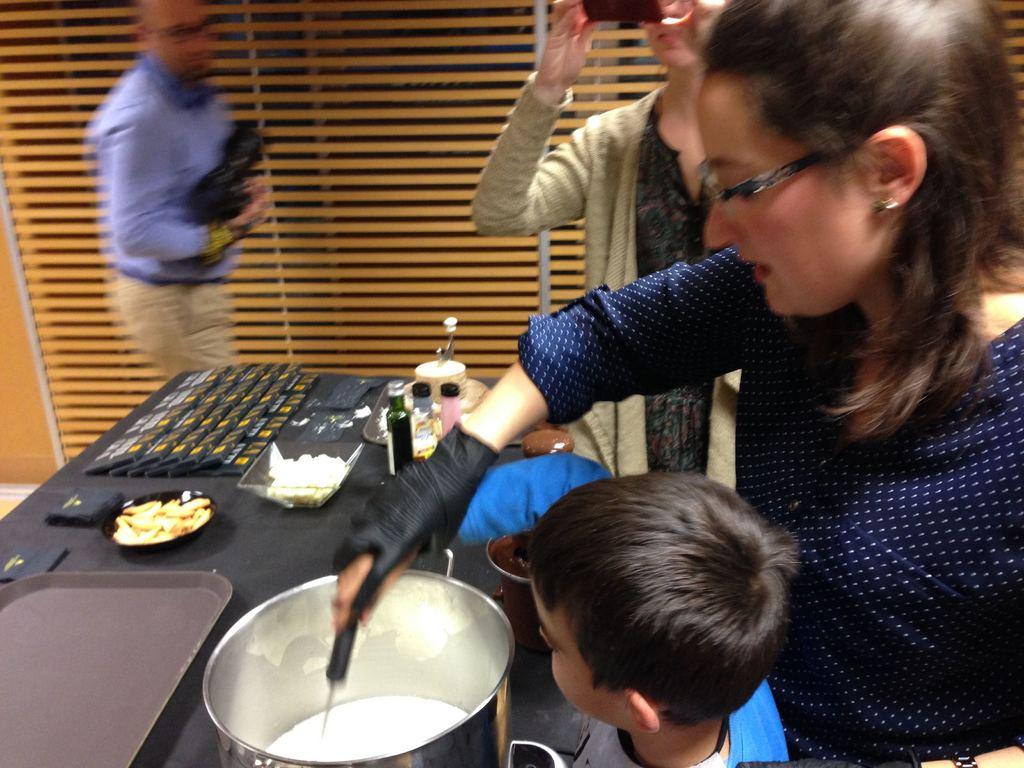Who or what is present in the image? There are people in the image. What is the primary object in the image? There is a table in the image. What is on the table? There are objects on the table. What type of objects are on the table? There are eatables on the table. How many dogs are sitting on the table in the image? There are no dogs present in the image; it only features people and objects on the table. 